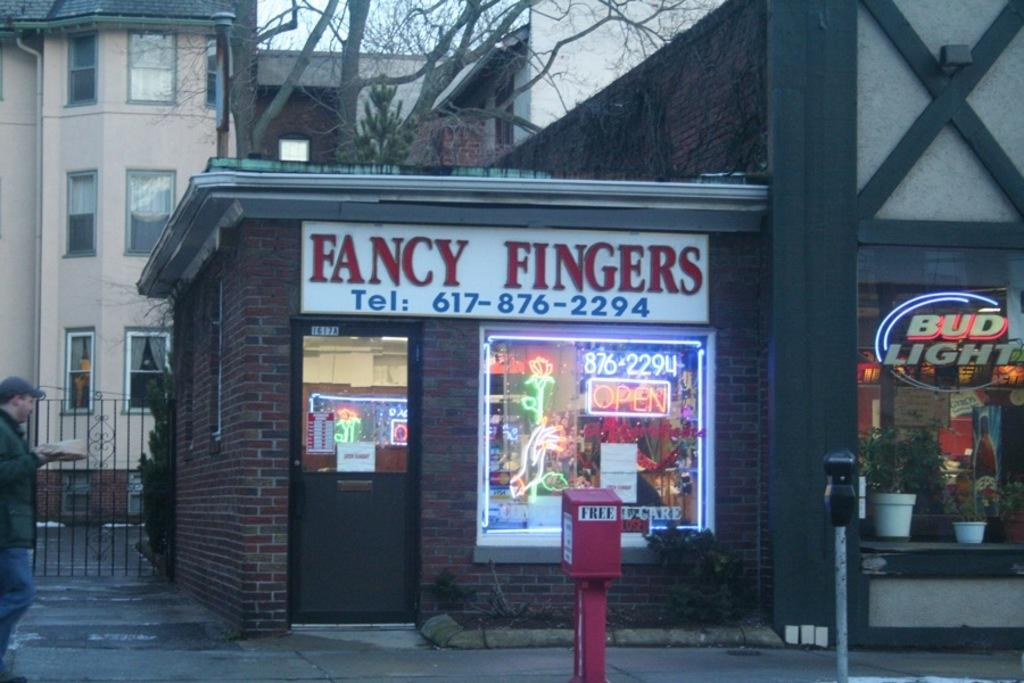<image>
Summarize the visual content of the image. A bud Light sign is next to the business Fancy Fingers. 